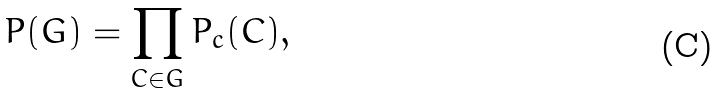<formula> <loc_0><loc_0><loc_500><loc_500>P ( G ) = \prod _ { C \in G } P _ { c } ( C ) ,</formula> 